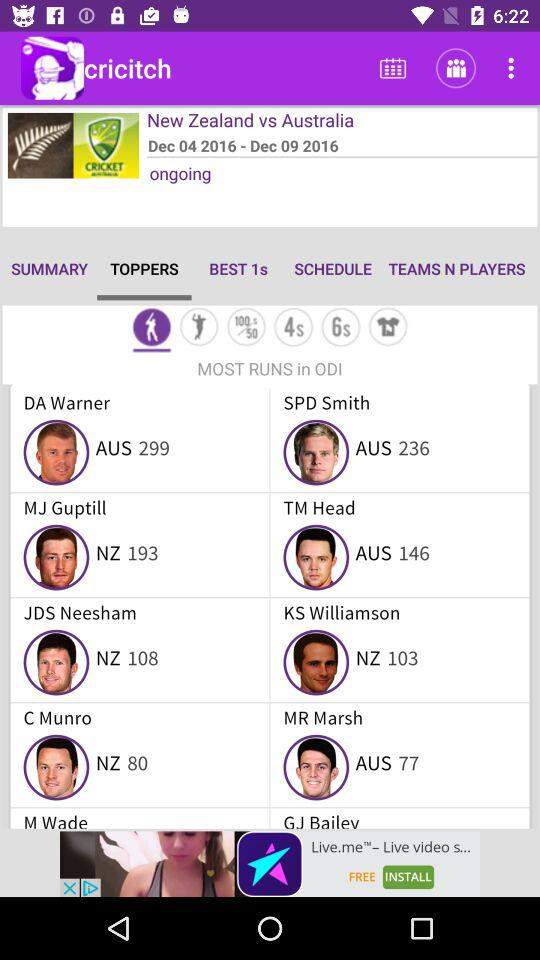Between which teams was cricket played? Cricket was played between "New Zealand" and "Australia". 